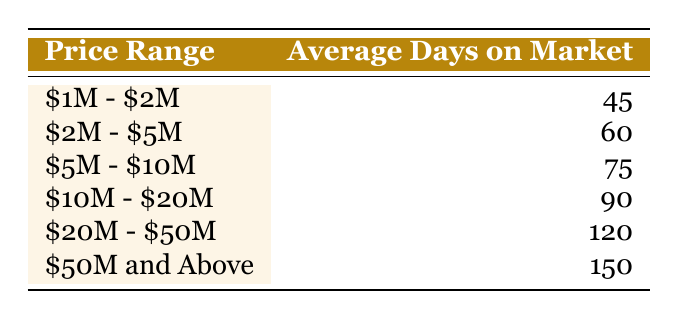What is the average days on market for homes priced between $5M and $10M? The table shows that for the price range of $5M - $10M, the average days on market is 75.
Answer: 75 How many more average days on market do homes in the $50M and above range take compared to the $1M to $2M range? The average days on market for $50M and above is 150, and for $1M - $2M it is 45. The difference is 150 - 45 = 105.
Answer: 105 Is the average days on market for the $20M to $50M range greater than 100 days? The table states the average days on market for $20M - $50M is 120, which is indeed greater than 100.
Answer: Yes What is the average of the average days on market for homes priced between $2M and $5M and $10M and $20M? The average days on market for $2M - $5M is 60 and for $10M - $20M it is 90. The average is (60 + 90) / 2 = 75.
Answer: 75 Which price range has the highest average days on market and what is that number? The price range with the highest average days on market is $50M and above, which is 150 days.
Answer: $50M and Above, 150 If you were to sum the average days on market for the $5M to $10M and $10M to $20M ranges, what would that total be? The average for $5M - $10M is 75 and for $10M - $20M it is 90. Their sum is 75 + 90 = 165.
Answer: 165 Do homes in the $2M to $5M range have fewer than 70 average days on market? The average for the $2M - $5M range is 60 days, which is less than 70.
Answer: Yes How does the average days on market for the $20M to $50M range compare to the overall average of all ranges combined? First, find the total of all average days on market: (45 + 60 + 75 + 90 + 120 + 150) = 540. There are 6 ranges, so the overall average is 540 / 6 = 90. The $20M to $50M range has 120 days, which is greater than 90.
Answer: Greater What are the average days on market for homes priced below $10M? The average days on market for homes below $10M can be calculated from the $1M - $2M, $2M - $5M, and $5M - $10M ranges: (45 + 60 + 75) / 3 = 60.
Answer: 60 